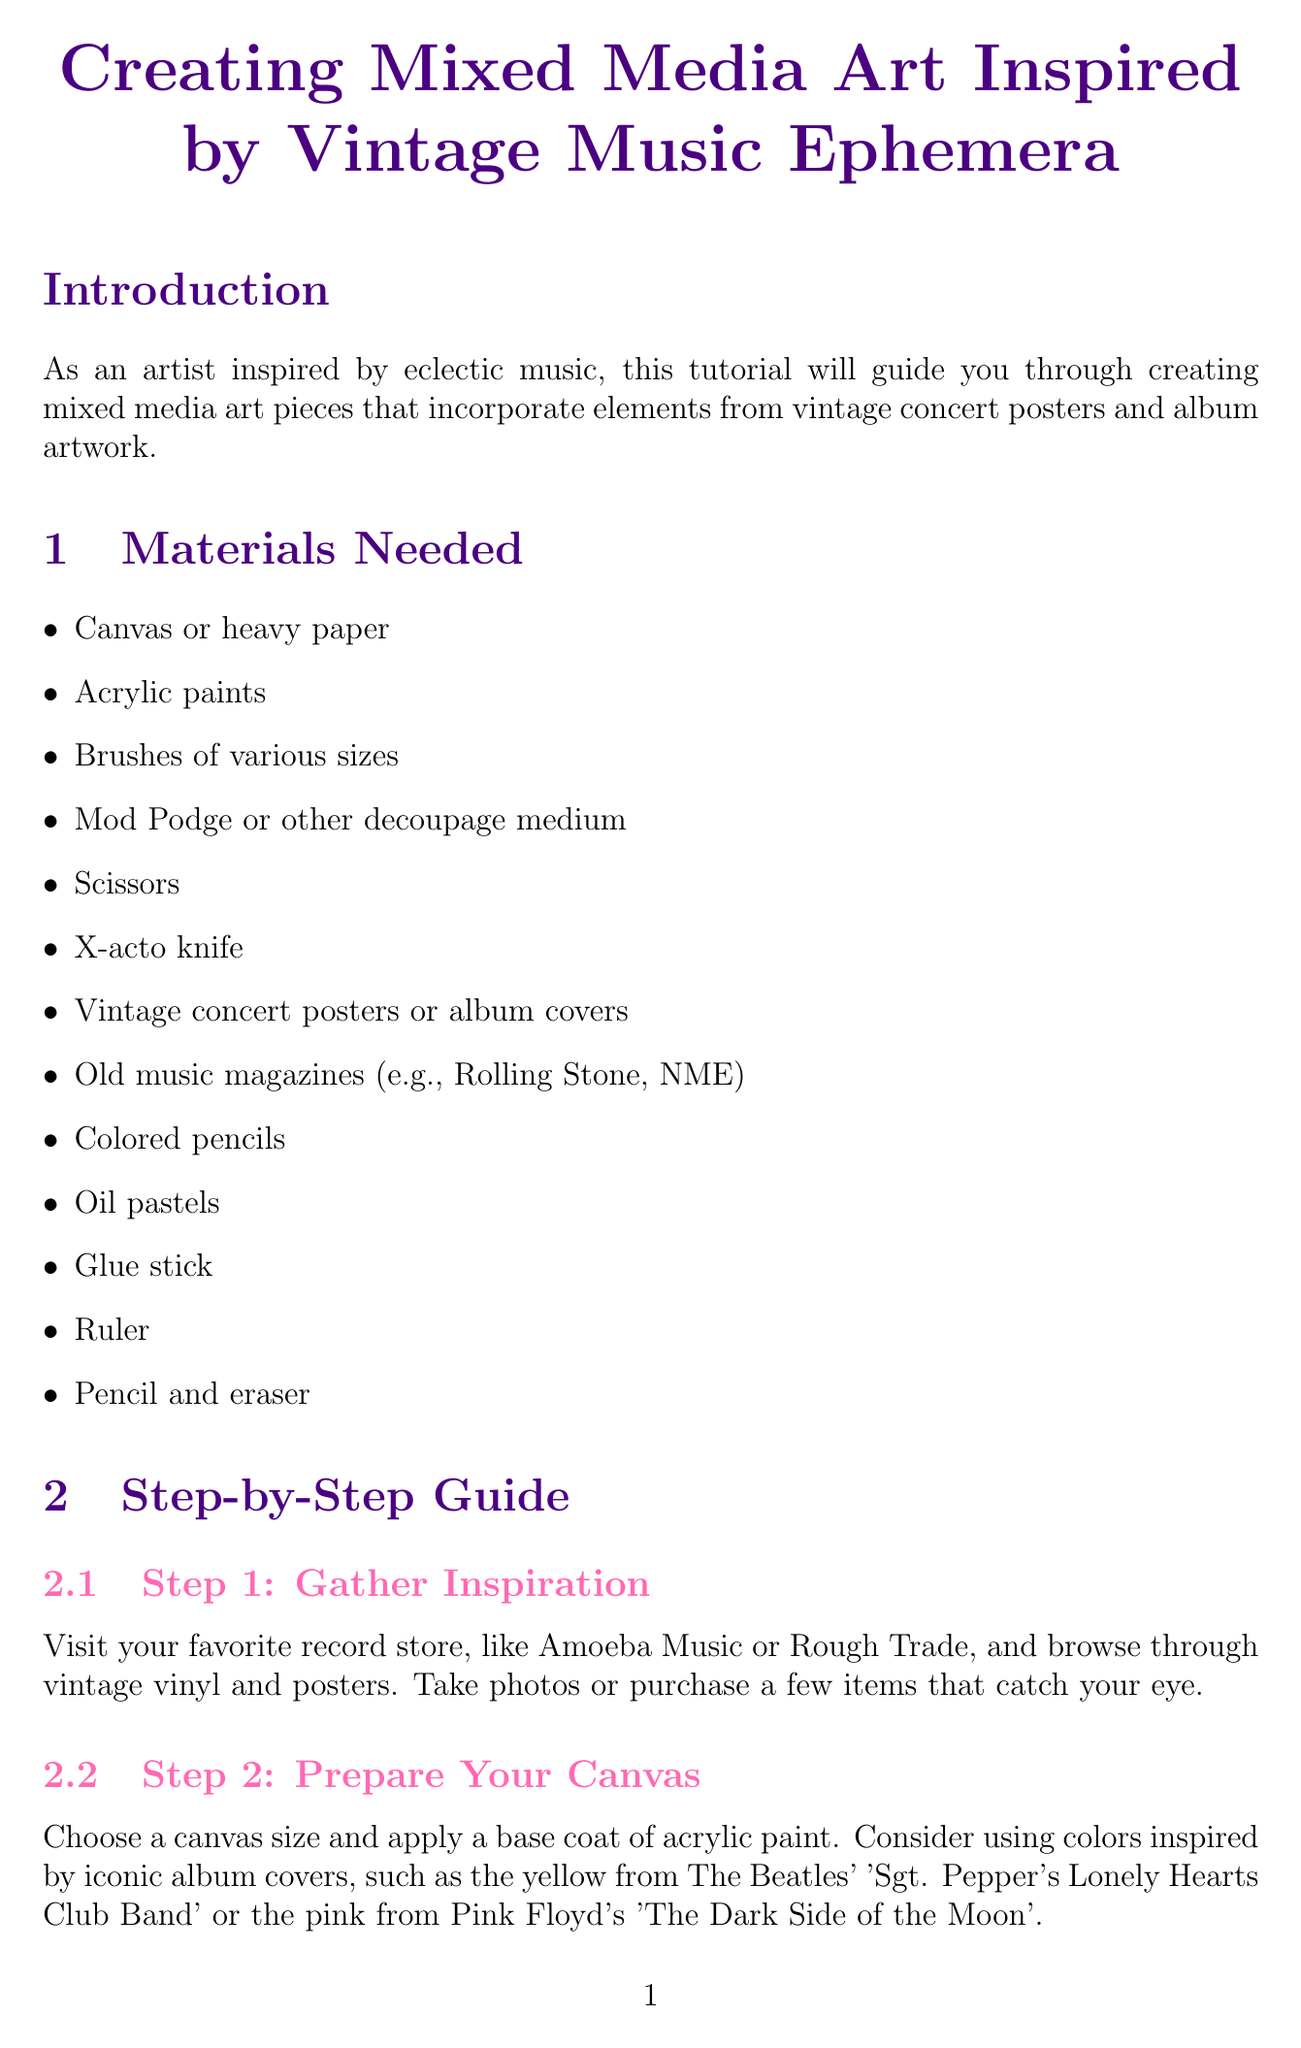What is the title of the tutorial? The title is explicitly stated at the beginning of the document and represents the main subject of the tutorial.
Answer: Creating Mixed Media Art Inspired by Vintage Music Ephemera How many materials are needed? The document lists a total of twelve materials required for the art project in one section.
Answer: 12 What technique is suggested to create texture? The document specifies techniques to create texture, mentioned in one of the steps.
Answer: Dry brushing or sponging Which song's lyrics could be included in the artwork? The document suggests incorporating personal elements, such as lyrics from one's favorite songs, highlighting the freedom of expression in the project.
Answer: Favorite songs What should be used to seal the artwork? This detail is found in the final step of the process, explaining how to protect the artwork once completed.
Answer: Mod Podge What kind of magazines are recommended for collage elements? Old music magazines are specifically mentioned as sources for collage elements in the materials needed section.
Answer: Music magazines Which exhibition is suggested as a resource? The document provides a list of resources, including exhibitions that relate to the subject, citing one specific example.
Answer: The Art of Rock: Posters from Presley to Punk What type of media should be used to enhance the art? The document indicates different media types that can be applied to enhance the depth and texture, encouraging artistic variety.
Answer: Colored pencils or oil pastels 